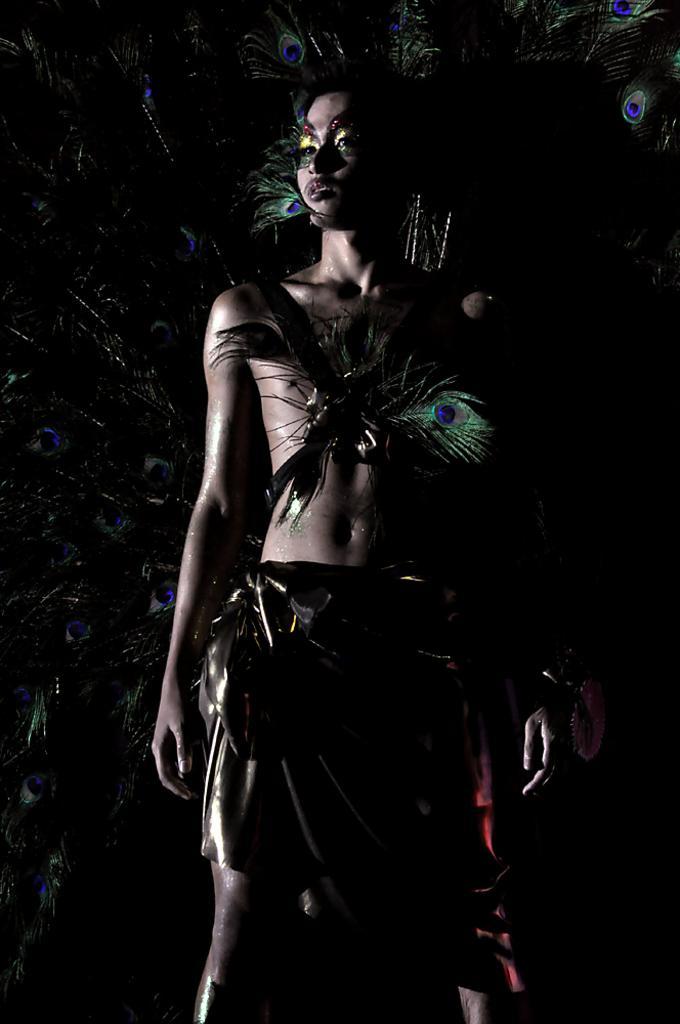How would you summarize this image in a sentence or two? In this image I can see the person standing, background I can see few feathers of the peacock and the feathers are in blue and green color. 